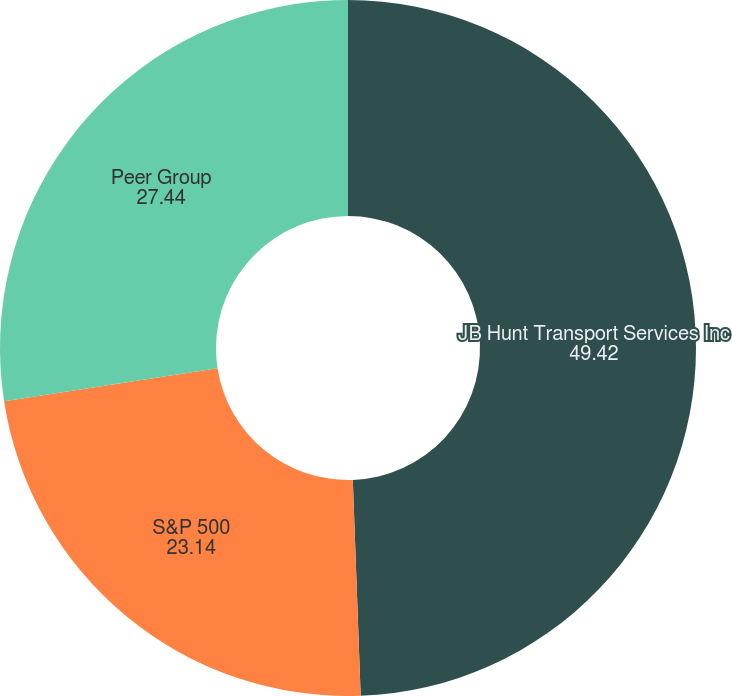<chart> <loc_0><loc_0><loc_500><loc_500><pie_chart><fcel>JB Hunt Transport Services Inc<fcel>S&P 500<fcel>Peer Group<nl><fcel>49.42%<fcel>23.14%<fcel>27.44%<nl></chart> 